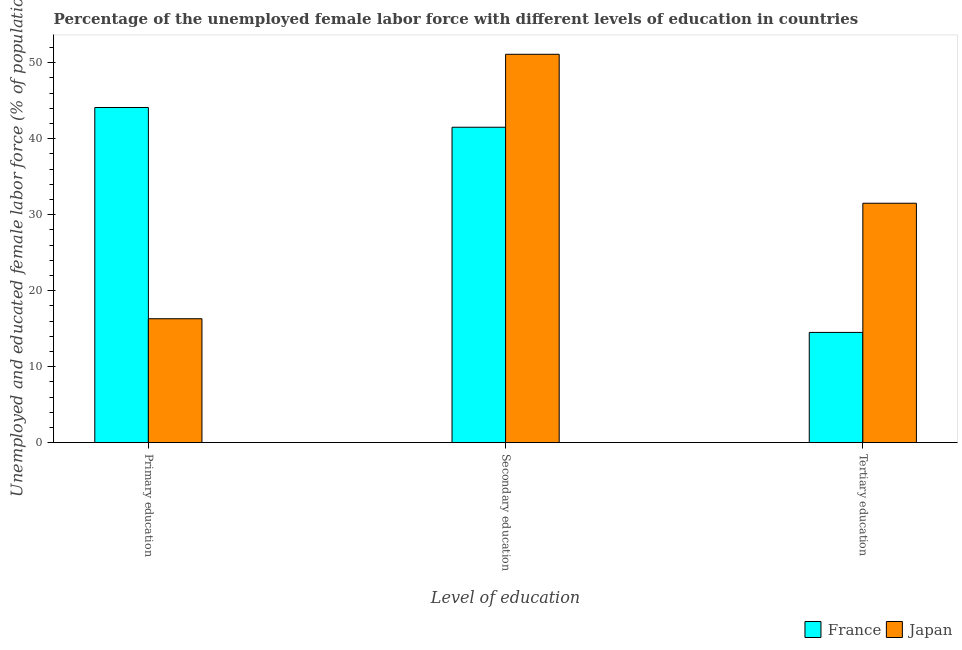How many different coloured bars are there?
Make the answer very short. 2. How many groups of bars are there?
Your answer should be very brief. 3. Are the number of bars per tick equal to the number of legend labels?
Offer a terse response. Yes. Are the number of bars on each tick of the X-axis equal?
Offer a terse response. Yes. How many bars are there on the 2nd tick from the right?
Give a very brief answer. 2. What is the percentage of female labor force who received secondary education in Japan?
Offer a very short reply. 51.1. Across all countries, what is the maximum percentage of female labor force who received tertiary education?
Your answer should be compact. 31.5. Across all countries, what is the minimum percentage of female labor force who received primary education?
Make the answer very short. 16.3. In which country was the percentage of female labor force who received tertiary education maximum?
Give a very brief answer. Japan. In which country was the percentage of female labor force who received primary education minimum?
Your answer should be very brief. Japan. What is the total percentage of female labor force who received primary education in the graph?
Give a very brief answer. 60.4. What is the difference between the percentage of female labor force who received primary education in France and that in Japan?
Your answer should be compact. 27.8. What is the difference between the percentage of female labor force who received tertiary education in Japan and the percentage of female labor force who received primary education in France?
Your answer should be compact. -12.6. What is the average percentage of female labor force who received secondary education per country?
Make the answer very short. 46.3. What is the difference between the percentage of female labor force who received tertiary education and percentage of female labor force who received primary education in Japan?
Provide a short and direct response. 15.2. What is the ratio of the percentage of female labor force who received tertiary education in France to that in Japan?
Provide a succinct answer. 0.46. What is the difference between the highest and the second highest percentage of female labor force who received secondary education?
Your answer should be compact. 9.6. What is the difference between the highest and the lowest percentage of female labor force who received secondary education?
Make the answer very short. 9.6. In how many countries, is the percentage of female labor force who received tertiary education greater than the average percentage of female labor force who received tertiary education taken over all countries?
Keep it short and to the point. 1. What does the 1st bar from the left in Primary education represents?
Provide a succinct answer. France. What does the 2nd bar from the right in Secondary education represents?
Your response must be concise. France. How many bars are there?
Offer a terse response. 6. Are all the bars in the graph horizontal?
Offer a very short reply. No. How many countries are there in the graph?
Give a very brief answer. 2. Does the graph contain any zero values?
Ensure brevity in your answer.  No. Does the graph contain grids?
Give a very brief answer. No. Where does the legend appear in the graph?
Your answer should be compact. Bottom right. How many legend labels are there?
Ensure brevity in your answer.  2. What is the title of the graph?
Your answer should be compact. Percentage of the unemployed female labor force with different levels of education in countries. What is the label or title of the X-axis?
Provide a short and direct response. Level of education. What is the label or title of the Y-axis?
Your response must be concise. Unemployed and educated female labor force (% of population). What is the Unemployed and educated female labor force (% of population) in France in Primary education?
Give a very brief answer. 44.1. What is the Unemployed and educated female labor force (% of population) of Japan in Primary education?
Your response must be concise. 16.3. What is the Unemployed and educated female labor force (% of population) of France in Secondary education?
Provide a succinct answer. 41.5. What is the Unemployed and educated female labor force (% of population) in Japan in Secondary education?
Your answer should be compact. 51.1. What is the Unemployed and educated female labor force (% of population) in France in Tertiary education?
Give a very brief answer. 14.5. What is the Unemployed and educated female labor force (% of population) in Japan in Tertiary education?
Give a very brief answer. 31.5. Across all Level of education, what is the maximum Unemployed and educated female labor force (% of population) in France?
Offer a very short reply. 44.1. Across all Level of education, what is the maximum Unemployed and educated female labor force (% of population) of Japan?
Offer a terse response. 51.1. Across all Level of education, what is the minimum Unemployed and educated female labor force (% of population) of France?
Make the answer very short. 14.5. Across all Level of education, what is the minimum Unemployed and educated female labor force (% of population) of Japan?
Ensure brevity in your answer.  16.3. What is the total Unemployed and educated female labor force (% of population) in France in the graph?
Provide a short and direct response. 100.1. What is the total Unemployed and educated female labor force (% of population) in Japan in the graph?
Keep it short and to the point. 98.9. What is the difference between the Unemployed and educated female labor force (% of population) in France in Primary education and that in Secondary education?
Make the answer very short. 2.6. What is the difference between the Unemployed and educated female labor force (% of population) in Japan in Primary education and that in Secondary education?
Provide a succinct answer. -34.8. What is the difference between the Unemployed and educated female labor force (% of population) in France in Primary education and that in Tertiary education?
Keep it short and to the point. 29.6. What is the difference between the Unemployed and educated female labor force (% of population) of Japan in Primary education and that in Tertiary education?
Provide a short and direct response. -15.2. What is the difference between the Unemployed and educated female labor force (% of population) in France in Secondary education and that in Tertiary education?
Your answer should be compact. 27. What is the difference between the Unemployed and educated female labor force (% of population) in Japan in Secondary education and that in Tertiary education?
Your answer should be very brief. 19.6. What is the difference between the Unemployed and educated female labor force (% of population) of France in Primary education and the Unemployed and educated female labor force (% of population) of Japan in Tertiary education?
Provide a succinct answer. 12.6. What is the difference between the Unemployed and educated female labor force (% of population) of France in Secondary education and the Unemployed and educated female labor force (% of population) of Japan in Tertiary education?
Your answer should be compact. 10. What is the average Unemployed and educated female labor force (% of population) in France per Level of education?
Provide a succinct answer. 33.37. What is the average Unemployed and educated female labor force (% of population) in Japan per Level of education?
Your answer should be compact. 32.97. What is the difference between the Unemployed and educated female labor force (% of population) in France and Unemployed and educated female labor force (% of population) in Japan in Primary education?
Ensure brevity in your answer.  27.8. What is the ratio of the Unemployed and educated female labor force (% of population) of France in Primary education to that in Secondary education?
Offer a terse response. 1.06. What is the ratio of the Unemployed and educated female labor force (% of population) in Japan in Primary education to that in Secondary education?
Ensure brevity in your answer.  0.32. What is the ratio of the Unemployed and educated female labor force (% of population) of France in Primary education to that in Tertiary education?
Your response must be concise. 3.04. What is the ratio of the Unemployed and educated female labor force (% of population) of Japan in Primary education to that in Tertiary education?
Ensure brevity in your answer.  0.52. What is the ratio of the Unemployed and educated female labor force (% of population) in France in Secondary education to that in Tertiary education?
Provide a succinct answer. 2.86. What is the ratio of the Unemployed and educated female labor force (% of population) of Japan in Secondary education to that in Tertiary education?
Provide a succinct answer. 1.62. What is the difference between the highest and the second highest Unemployed and educated female labor force (% of population) of France?
Provide a short and direct response. 2.6. What is the difference between the highest and the second highest Unemployed and educated female labor force (% of population) in Japan?
Your answer should be very brief. 19.6. What is the difference between the highest and the lowest Unemployed and educated female labor force (% of population) of France?
Provide a short and direct response. 29.6. What is the difference between the highest and the lowest Unemployed and educated female labor force (% of population) of Japan?
Your response must be concise. 34.8. 